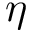<formula> <loc_0><loc_0><loc_500><loc_500>\eta</formula> 